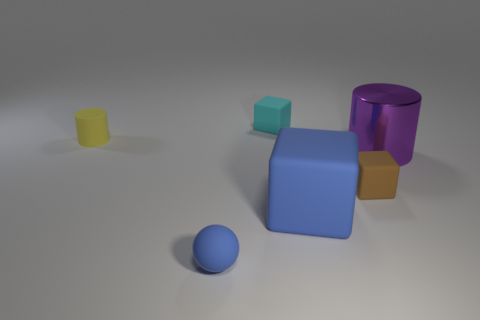How many things are either tiny rubber blocks that are in front of the big purple metallic cylinder or matte objects on the left side of the cyan block?
Keep it short and to the point. 3. What is the shape of the yellow rubber object?
Make the answer very short. Cylinder. What number of other things are there of the same material as the small sphere
Offer a very short reply. 4. There is a brown thing that is the same shape as the big blue thing; what is its size?
Keep it short and to the point. Small. What is the material of the block that is in front of the small rubber block that is right of the small block that is behind the brown rubber cube?
Your answer should be very brief. Rubber. Are any yellow cylinders visible?
Provide a short and direct response. Yes. There is a large metal thing; is it the same color as the matte object that is on the left side of the tiny ball?
Your answer should be very brief. No. What color is the large shiny cylinder?
Make the answer very short. Purple. Are there any other things that have the same shape as the tiny cyan rubber thing?
Your answer should be very brief. Yes. What is the color of the small rubber thing that is the same shape as the large purple object?
Your response must be concise. Yellow. 